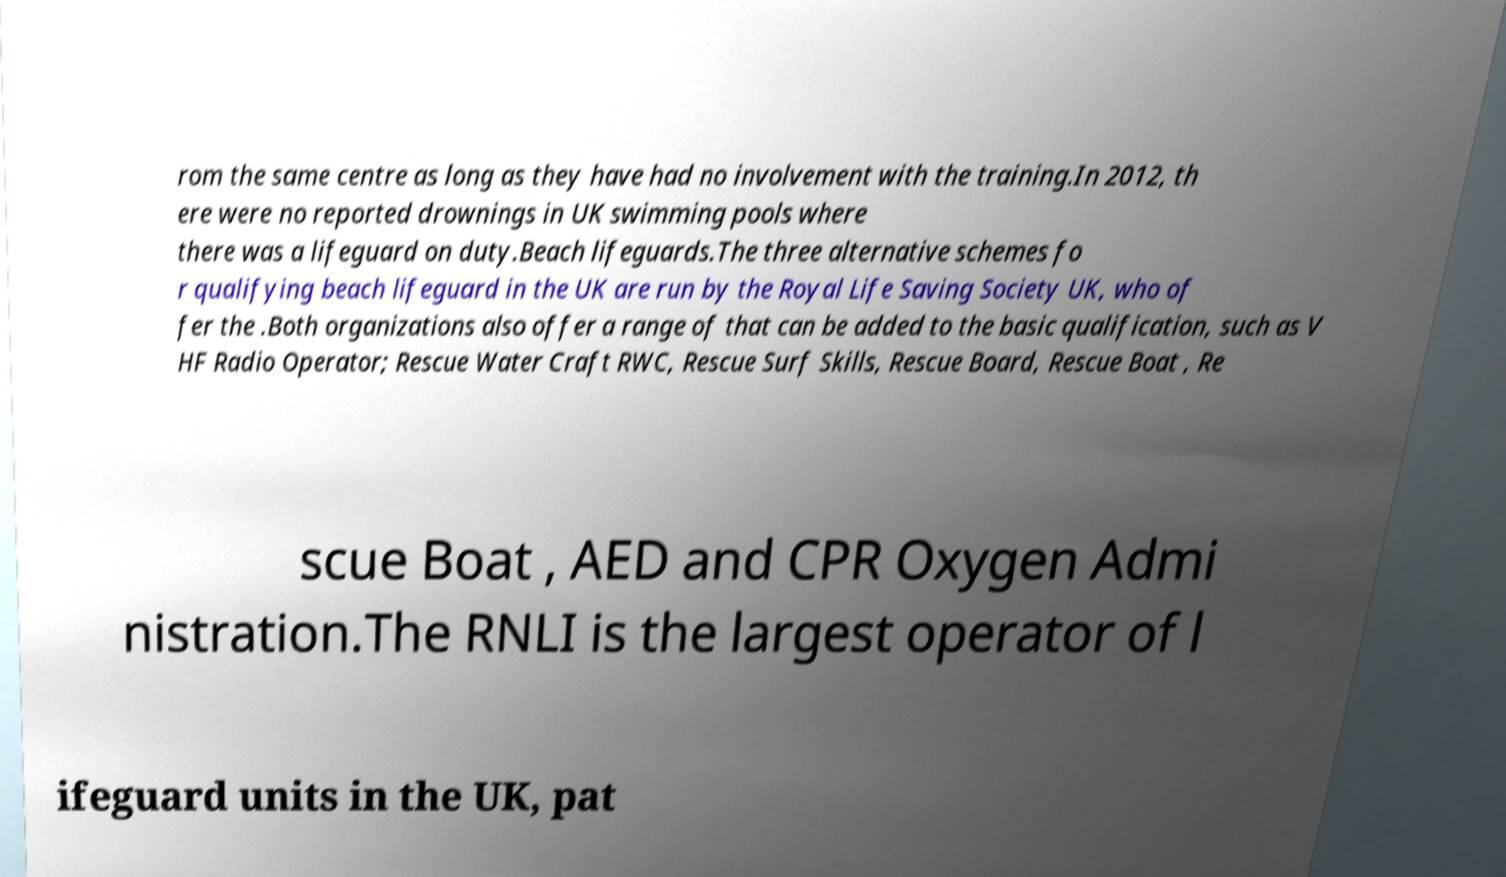Please identify and transcribe the text found in this image. rom the same centre as long as they have had no involvement with the training.In 2012, th ere were no reported drownings in UK swimming pools where there was a lifeguard on duty.Beach lifeguards.The three alternative schemes fo r qualifying beach lifeguard in the UK are run by the Royal Life Saving Society UK, who of fer the .Both organizations also offer a range of that can be added to the basic qualification, such as V HF Radio Operator; Rescue Water Craft RWC, Rescue Surf Skills, Rescue Board, Rescue Boat , Re scue Boat , AED and CPR Oxygen Admi nistration.The RNLI is the largest operator of l ifeguard units in the UK, pat 